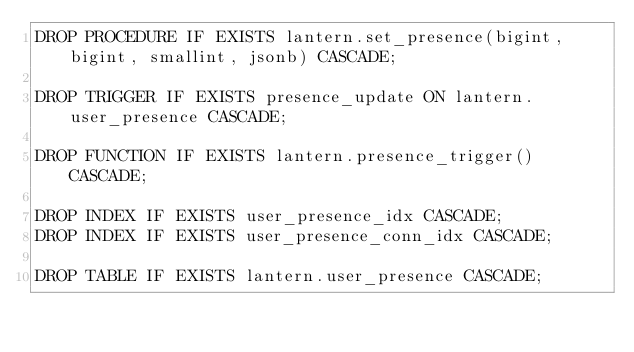<code> <loc_0><loc_0><loc_500><loc_500><_SQL_>DROP PROCEDURE IF EXISTS lantern.set_presence(bigint, bigint, smallint, jsonb) CASCADE;

DROP TRIGGER IF EXISTS presence_update ON lantern.user_presence CASCADE;

DROP FUNCTION IF EXISTS lantern.presence_trigger() CASCADE;

DROP INDEX IF EXISTS user_presence_idx CASCADE;
DROP INDEX IF EXISTS user_presence_conn_idx CASCADE;

DROP TABLE IF EXISTS lantern.user_presence CASCADE;</code> 